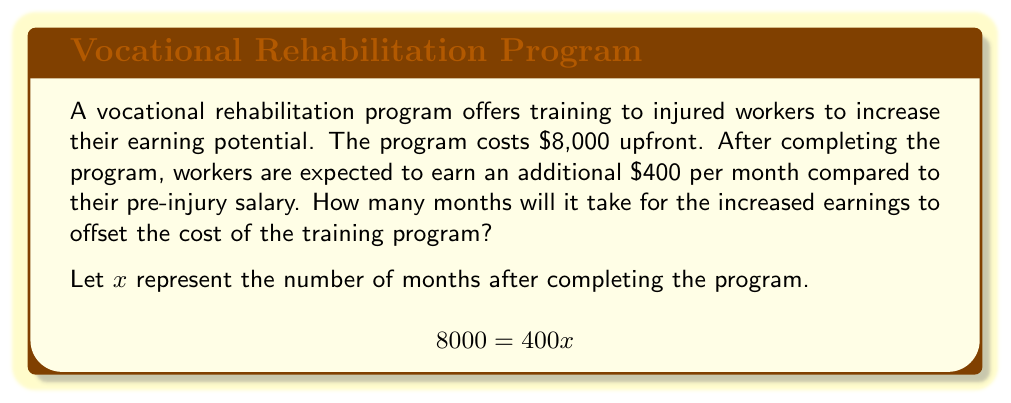What is the answer to this math problem? To solve this problem, we need to set up an equation where the cost of the program equals the total increased earnings over time:

1. The cost of the program is $8,000
2. The monthly increase in earnings is $400
3. Let $x$ be the number of months after completing the program

We can express this as the equation:

$$8000 = 400x$$

To solve for $x$, we divide both sides by 400:

$$\frac{8000}{400} = \frac{400x}{400}$$

$$20 = x$$

This means it will take 20 months for the increased earnings to equal the cost of the program.

To verify:
$$20 \text{ months} \times \$400 \text{ per month} = \$8000$$

Therefore, after 20 months, the total increased earnings will equal the cost of the vocational training program, reaching the break-even point.
Answer: $20$ months 